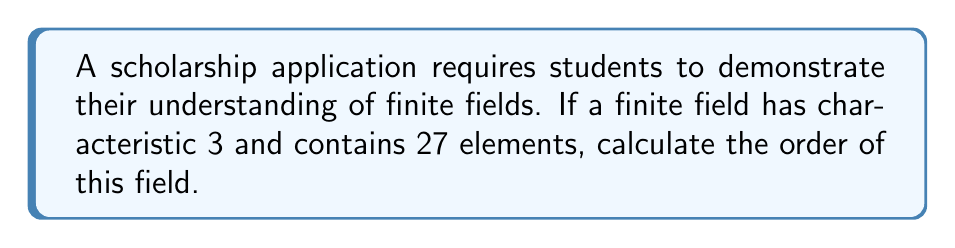Could you help me with this problem? Let's approach this step-by-step:

1) In a finite field, the number of elements is always a power of its characteristic. We can express this as:

   $$ |F| = p^n $$

   where $|F|$ is the number of elements in the field, $p$ is the characteristic of the field, and $n$ is some positive integer.

2) We're given that the characteristic is 3 and the field contains 27 elements. So we have:

   $$ 27 = 3^n $$

3) To find $n$, we need to solve this equation. We can do this by using logarithms:

   $$ \log_3(27) = \log_3(3^n) $$

4) Using the properties of logarithms, this simplifies to:

   $$ \log_3(27) = n $$

5) We know that $3^3 = 27$, so:

   $$ n = 3 $$

6) The order of a finite field is the number of elements it contains. In this case, the order is 27.
Answer: 27 